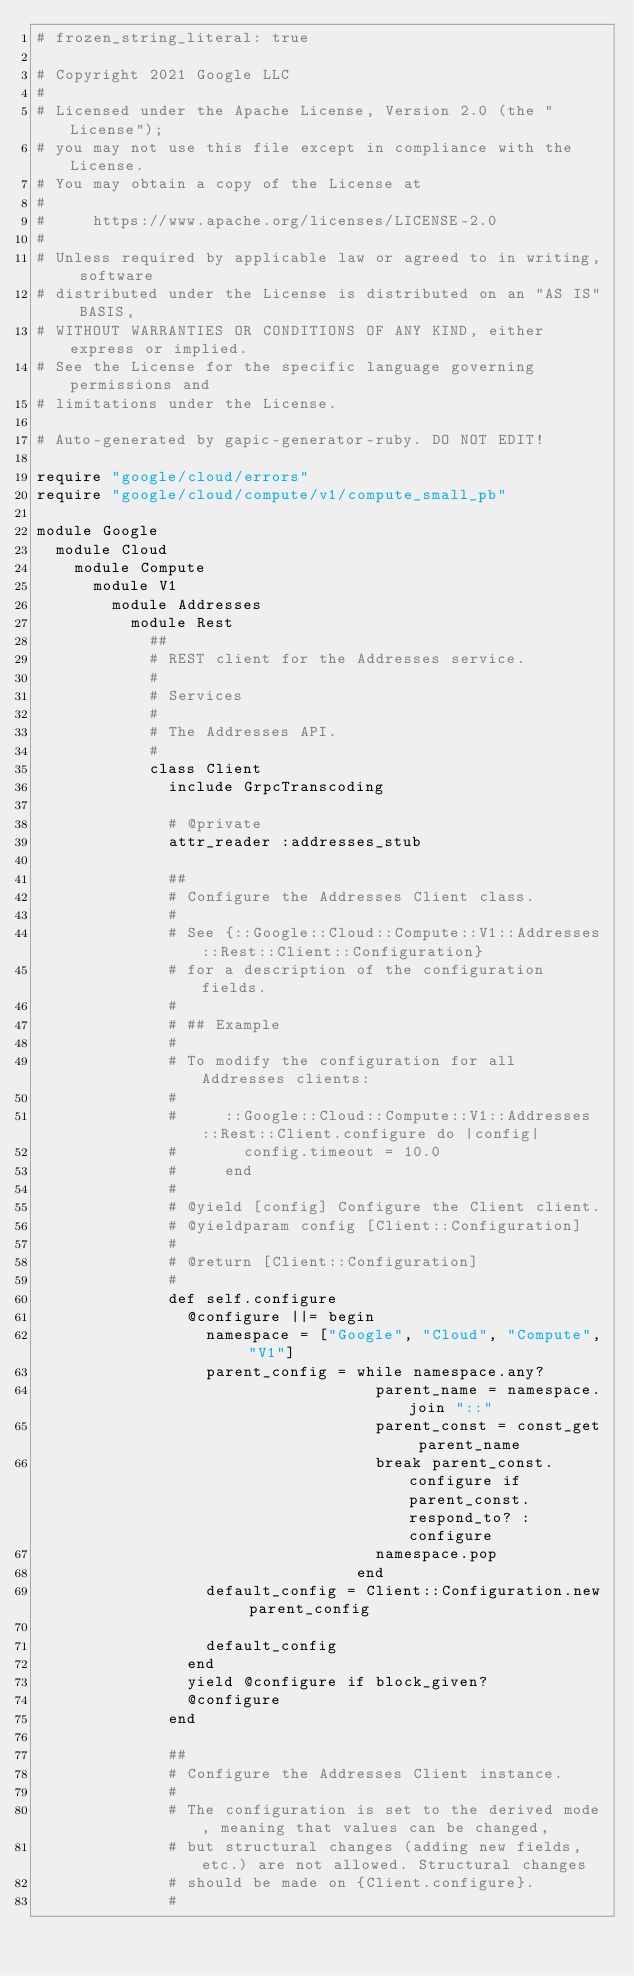<code> <loc_0><loc_0><loc_500><loc_500><_Ruby_># frozen_string_literal: true

# Copyright 2021 Google LLC
#
# Licensed under the Apache License, Version 2.0 (the "License");
# you may not use this file except in compliance with the License.
# You may obtain a copy of the License at
#
#     https://www.apache.org/licenses/LICENSE-2.0
#
# Unless required by applicable law or agreed to in writing, software
# distributed under the License is distributed on an "AS IS" BASIS,
# WITHOUT WARRANTIES OR CONDITIONS OF ANY KIND, either express or implied.
# See the License for the specific language governing permissions and
# limitations under the License.

# Auto-generated by gapic-generator-ruby. DO NOT EDIT!

require "google/cloud/errors"
require "google/cloud/compute/v1/compute_small_pb"

module Google
  module Cloud
    module Compute
      module V1
        module Addresses
          module Rest
            ##
            # REST client for the Addresses service.
            #
            # Services
            #
            # The Addresses API.
            #
            class Client
              include GrpcTranscoding

              # @private
              attr_reader :addresses_stub

              ##
              # Configure the Addresses Client class.
              #
              # See {::Google::Cloud::Compute::V1::Addresses::Rest::Client::Configuration}
              # for a description of the configuration fields.
              #
              # ## Example
              #
              # To modify the configuration for all Addresses clients:
              #
              #     ::Google::Cloud::Compute::V1::Addresses::Rest::Client.configure do |config|
              #       config.timeout = 10.0
              #     end
              #
              # @yield [config] Configure the Client client.
              # @yieldparam config [Client::Configuration]
              #
              # @return [Client::Configuration]
              #
              def self.configure
                @configure ||= begin
                  namespace = ["Google", "Cloud", "Compute", "V1"]
                  parent_config = while namespace.any?
                                    parent_name = namespace.join "::"
                                    parent_const = const_get parent_name
                                    break parent_const.configure if parent_const.respond_to? :configure
                                    namespace.pop
                                  end
                  default_config = Client::Configuration.new parent_config

                  default_config
                end
                yield @configure if block_given?
                @configure
              end

              ##
              # Configure the Addresses Client instance.
              #
              # The configuration is set to the derived mode, meaning that values can be changed,
              # but structural changes (adding new fields, etc.) are not allowed. Structural changes
              # should be made on {Client.configure}.
              #</code> 